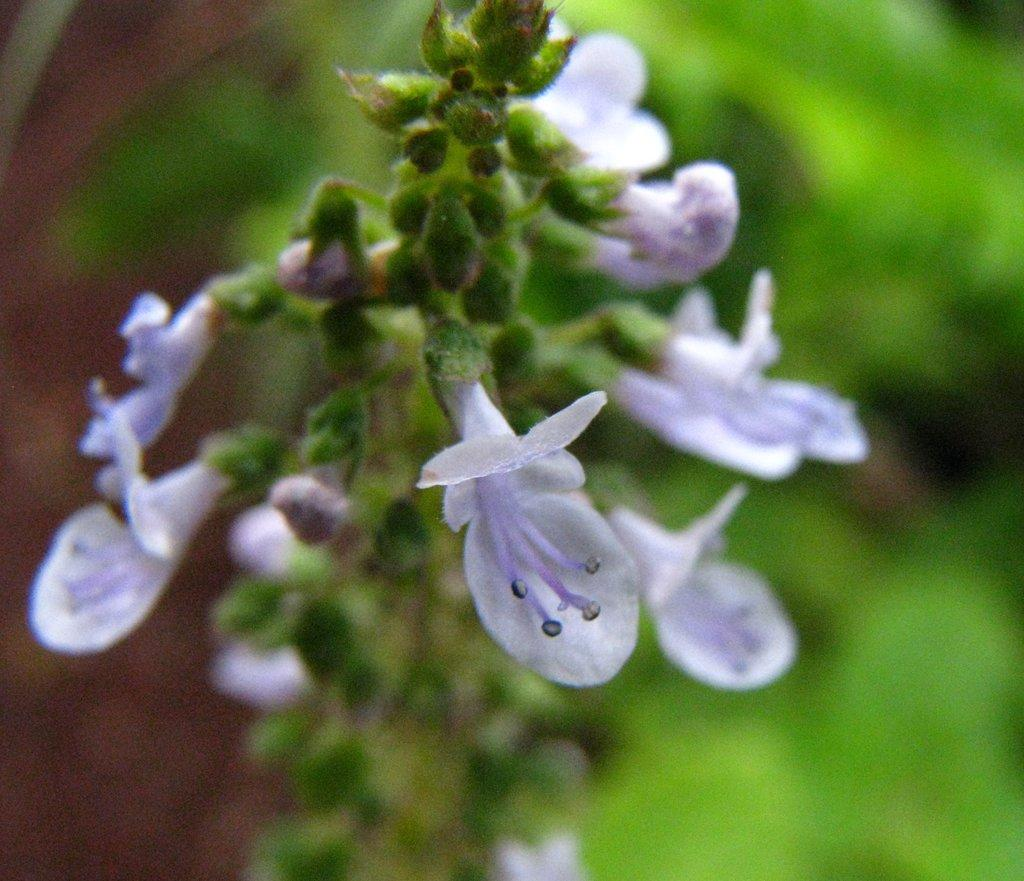What type of plants can be seen in the image? There are flowers in the image. Can you describe the flowers' growth stage? There are buds on the stems of the flowers. What can be observed about the background of the image? The background of the image appears green and is blurred. What type of poison is being used to treat the grandfather's illness in the image? There is no mention of poison, illness, or a grandfather in the image; it features flowers with buds on their stems and a green, blurred background. 